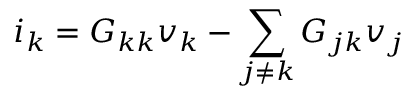<formula> <loc_0><loc_0><loc_500><loc_500>i _ { k } = G _ { k k } v _ { k } - \sum _ { j \neq k } G _ { j k } v _ { j }</formula> 